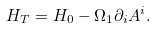Convert formula to latex. <formula><loc_0><loc_0><loc_500><loc_500>H _ { T } = H _ { 0 } - \Omega _ { 1 } \partial _ { i } A ^ { i } .</formula> 